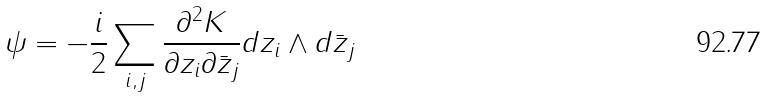<formula> <loc_0><loc_0><loc_500><loc_500>\psi = - \frac { i } { 2 } \sum _ { i , j } \frac { \partial ^ { 2 } K } { \partial z _ { i } \partial \bar { z } _ { j } } d z _ { i } \wedge d \bar { z } _ { j }</formula> 